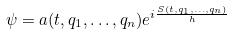<formula> <loc_0><loc_0><loc_500><loc_500>\psi = a ( t , q _ { 1 } , \dots , q _ { n } ) e ^ { i \frac { S ( t , q _ { 1 } , \dots , q _ { n } ) } { h } }</formula> 